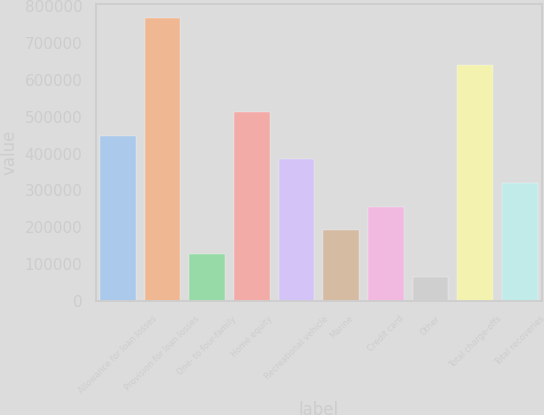Convert chart. <chart><loc_0><loc_0><loc_500><loc_500><bar_chart><fcel>Allowance for loan losses<fcel>Provision for loan losses<fcel>One- to four-family<fcel>Home equity<fcel>Recreational vehicle<fcel>Marine<fcel>Credit card<fcel>Other<fcel>Total charge-offs<fcel>Total recoveries<nl><fcel>448055<fcel>768093<fcel>128016<fcel>512063<fcel>384047<fcel>192024<fcel>256032<fcel>64008.4<fcel>640078<fcel>320039<nl></chart> 